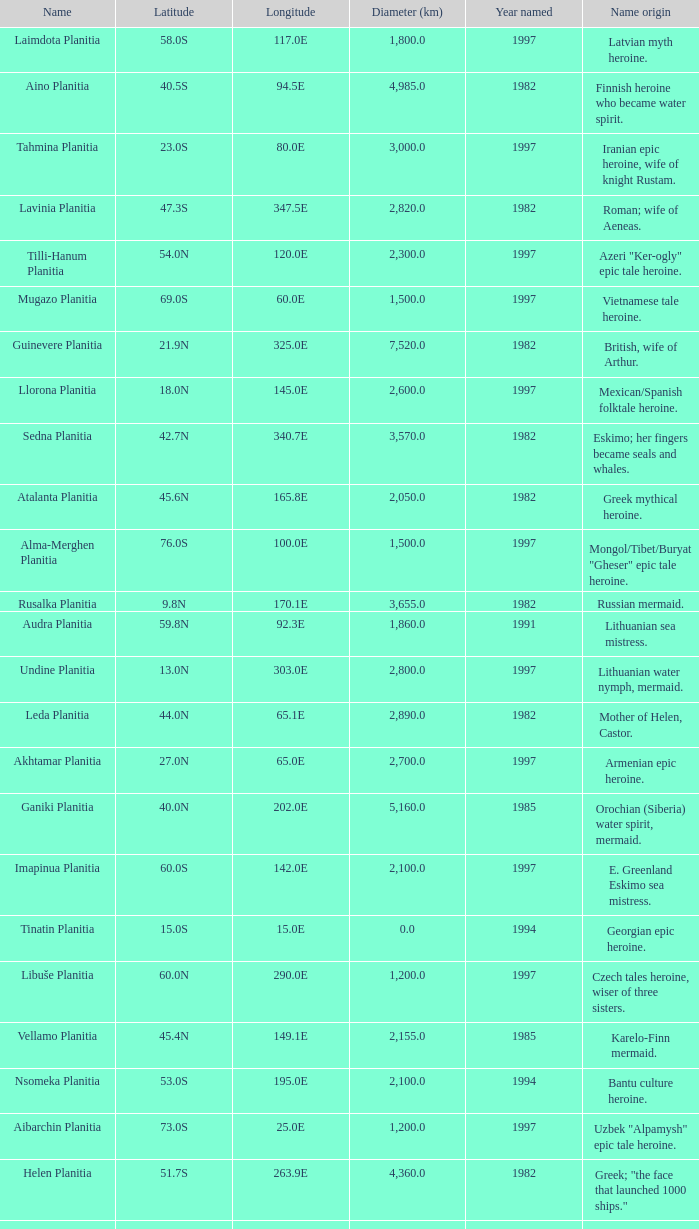What is the diameter (km) of feature of latitude 40.5s 4985.0. 